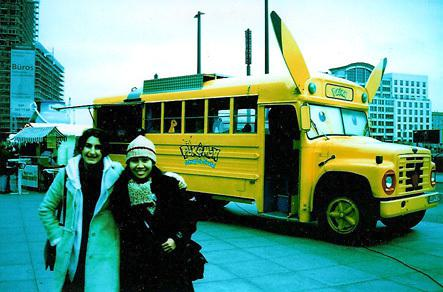What makes the bus in the image unique? The bus is uniquely designed with vibrant colors and elements that suggest it is a promotional vehicle for a themed event or product. The wing-like structure on top and the appealing design make it stand out. 